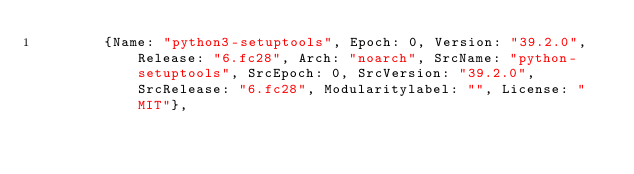<code> <loc_0><loc_0><loc_500><loc_500><_Go_>				{Name: "python3-setuptools", Epoch: 0, Version: "39.2.0", Release: "6.fc28", Arch: "noarch", SrcName: "python-setuptools", SrcEpoch: 0, SrcVersion: "39.2.0", SrcRelease: "6.fc28", Modularitylabel: "", License: "MIT"},</code> 